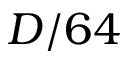<formula> <loc_0><loc_0><loc_500><loc_500>D / 6 4</formula> 